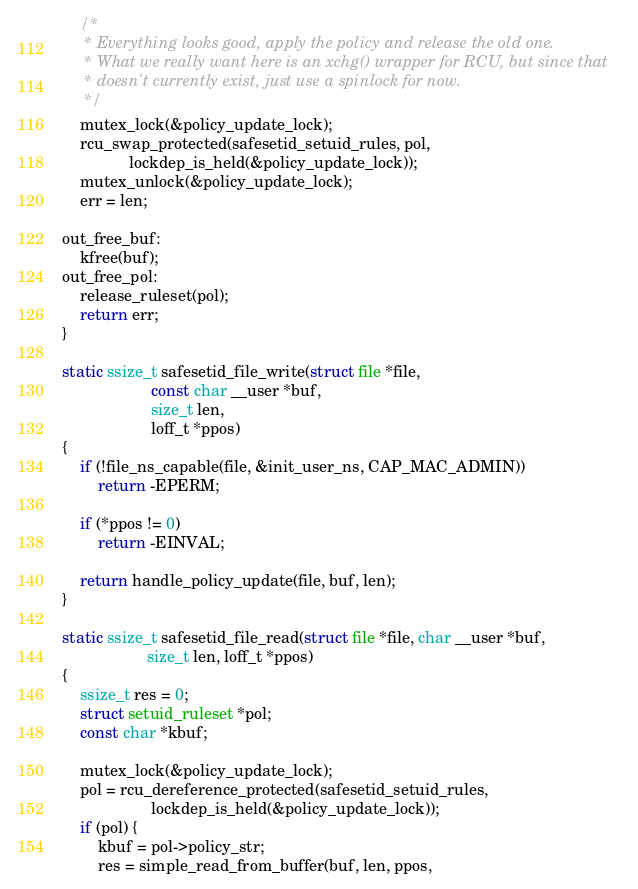Convert code to text. <code><loc_0><loc_0><loc_500><loc_500><_C_>
	/*
	 * Everything looks good, apply the policy and release the old one.
	 * What we really want here is an xchg() wrapper for RCU, but since that
	 * doesn't currently exist, just use a spinlock for now.
	 */
	mutex_lock(&policy_update_lock);
	rcu_swap_protected(safesetid_setuid_rules, pol,
			   lockdep_is_held(&policy_update_lock));
	mutex_unlock(&policy_update_lock);
	err = len;

out_free_buf:
	kfree(buf);
out_free_pol:
	release_ruleset(pol);
	return err;
}

static ssize_t safesetid_file_write(struct file *file,
				    const char __user *buf,
				    size_t len,
				    loff_t *ppos)
{
	if (!file_ns_capable(file, &init_user_ns, CAP_MAC_ADMIN))
		return -EPERM;

	if (*ppos != 0)
		return -EINVAL;

	return handle_policy_update(file, buf, len);
}

static ssize_t safesetid_file_read(struct file *file, char __user *buf,
				   size_t len, loff_t *ppos)
{
	ssize_t res = 0;
	struct setuid_ruleset *pol;
	const char *kbuf;

	mutex_lock(&policy_update_lock);
	pol = rcu_dereference_protected(safesetid_setuid_rules,
					lockdep_is_held(&policy_update_lock));
	if (pol) {
		kbuf = pol->policy_str;
		res = simple_read_from_buffer(buf, len, ppos,</code> 